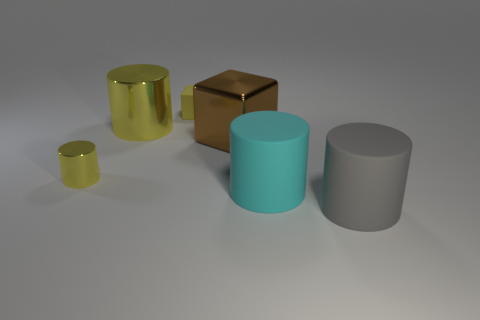Subtract all small yellow metal cylinders. How many cylinders are left? 3 Add 1 small blue matte cubes. How many objects exist? 7 Subtract all gray cylinders. How many cylinders are left? 3 Subtract 2 cylinders. How many cylinders are left? 2 Subtract 0 brown cylinders. How many objects are left? 6 Subtract all cylinders. How many objects are left? 2 Subtract all brown cylinders. Subtract all cyan spheres. How many cylinders are left? 4 Subtract all yellow cubes. How many yellow cylinders are left? 2 Subtract all red matte blocks. Subtract all large matte objects. How many objects are left? 4 Add 5 large yellow metallic cylinders. How many large yellow metallic cylinders are left? 6 